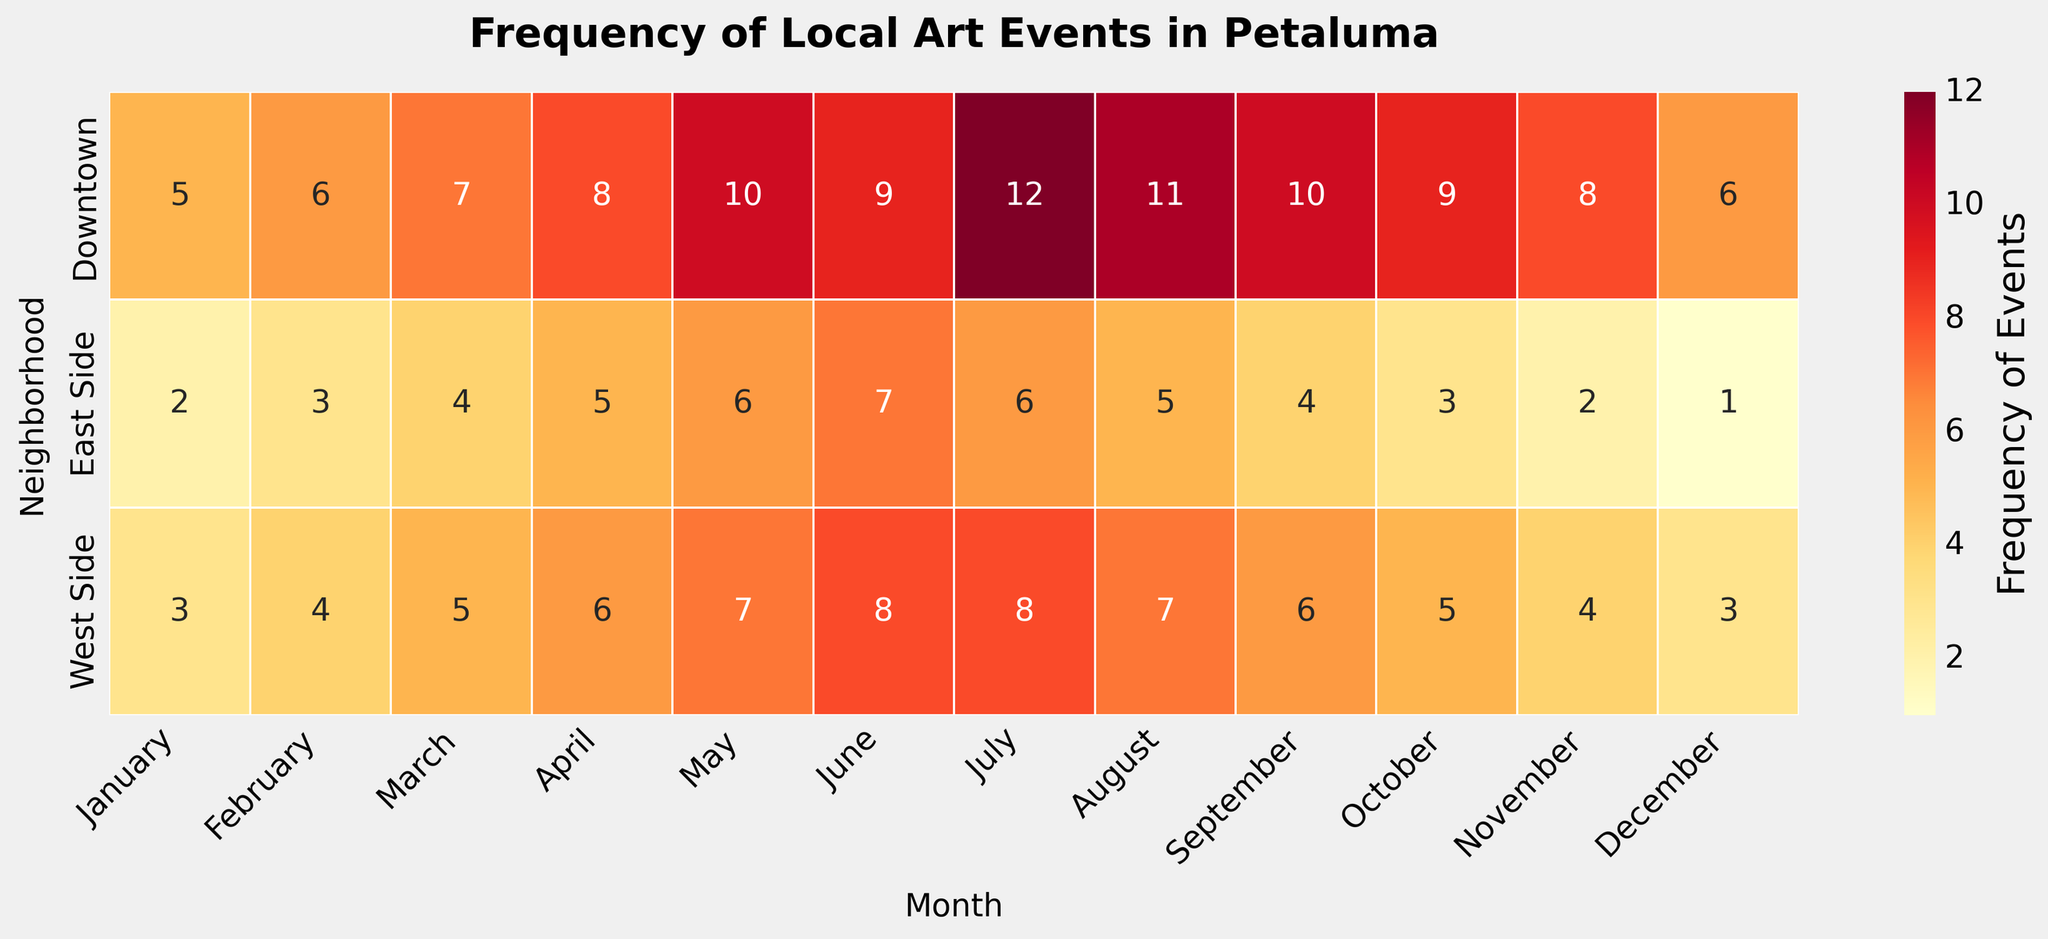Which neighborhood had the highest frequency of art events in July? Look for the row labeled 'Downtown' and the column labeled 'July.' The corresponding value is the highest frequency.
Answer: Downtown What is the average frequency of art events in the Downtown neighborhood over the year? Sum the values for Downtown across all months (5+6+7+8+10+9+12+11+10+9+8+6) and divide by 12. This equals (101 / 12), which is approximately 8.42.
Answer: 8.42 Which month had the lowest frequency of art events in East Side? Look for the row labeled 'East Side' and identify the smallest number across all months. December has the value 1, which is the lowest.
Answer: December How does the frequency of events in November compare between West Side and Downtown? Look in the column for 'November' and compare the values in the rows for 'West Side' (4) and 'Downtown' (8). Downtown has more events.
Answer: Downtown has more events What's the total frequency of art events in Petaluma in March? Add the frequencies for March across all neighborhoods: 7 (Downtown) + 5 (West Side) + 4 (East Side). This gives a total of 16.
Answer: 16 Did the frequency of art events in the West Side increase, decrease, or remain constant from January to June? Compare the West Side values for January through June: (3, 4, 5, 6, 7, 8). The values consistently increase each month.
Answer: Increase Which neighborhood has the highest frequency of events in May? Look for the values in May for all neighborhoods. The highest value is in Downtown with 10.
Answer: Downtown What is the difference in the total number of art events between Downtown and East Side for the entire year? Calculate the yearly totals for Downtown (101) and East Side (48), then find the difference: 101 - 48. The difference is 53.
Answer: 53 Which month showed the highest frequency of events in Petaluma across all neighborhoods? Look for the month with the highest sum of frequencies across neighborhoods. July has the highest total (12 (Downtown) + 8 (West Side) + 6 (East Side) = 26).
Answer: July 